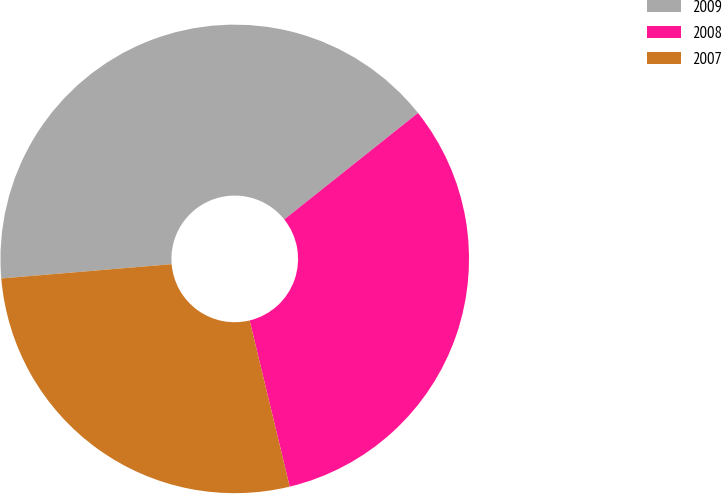Convert chart. <chart><loc_0><loc_0><loc_500><loc_500><pie_chart><fcel>2009<fcel>2008<fcel>2007<nl><fcel>40.63%<fcel>31.93%<fcel>27.44%<nl></chart> 